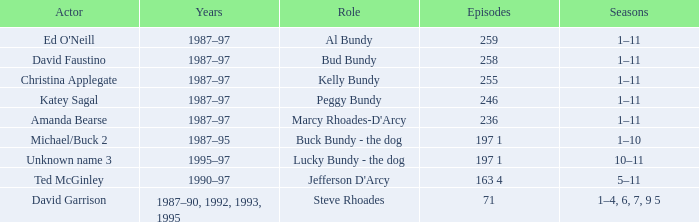How many years did the role of Steve Rhoades last? 1987–90, 1992, 1993, 1995. 